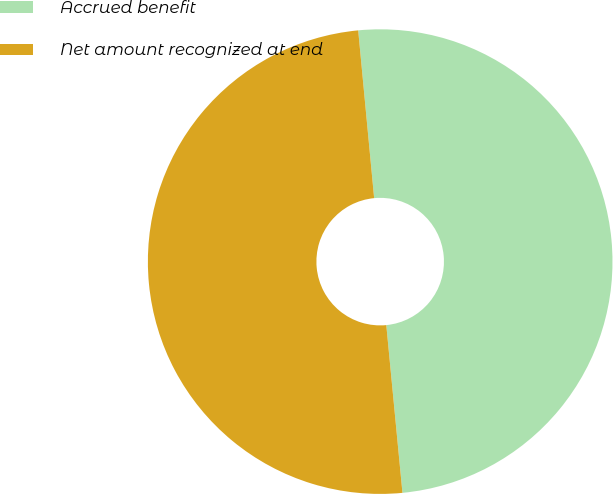Convert chart. <chart><loc_0><loc_0><loc_500><loc_500><pie_chart><fcel>Accrued benefit<fcel>Net amount recognized at end<nl><fcel>49.98%<fcel>50.02%<nl></chart> 